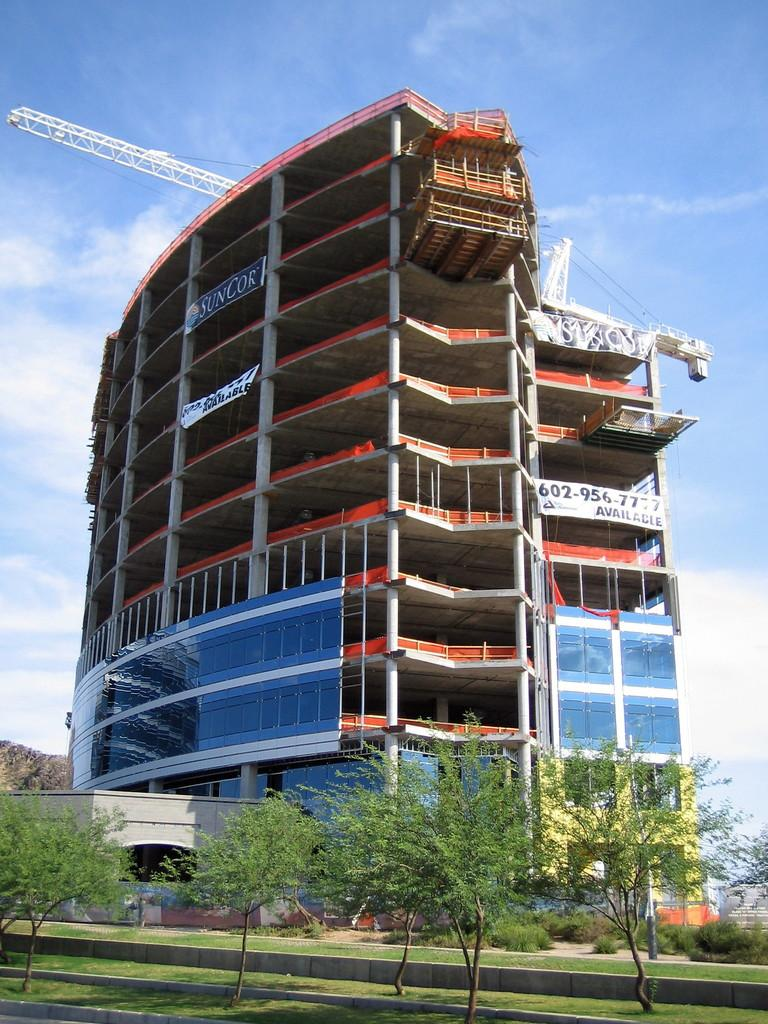What type of structure can be seen in the image? There is a building in the image. What is visible at the top of the image? The sky is visible at the top of the image. What type of vegetation is present in the image? There are plants in the image. What type of ground cover can be seen in the image? There is grass visible in the image. What type of surprise can be seen in the image? There is no surprise present in the image; it only features a building, the sky, plants, and grass. 